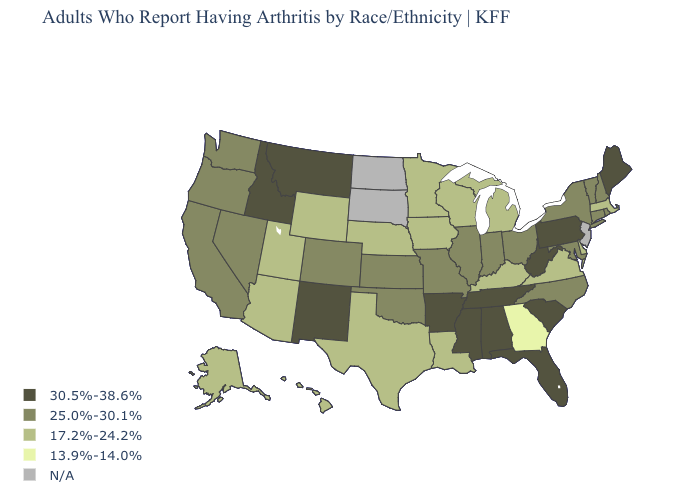Which states have the lowest value in the USA?
Give a very brief answer. Georgia. What is the value of Hawaii?
Answer briefly. 17.2%-24.2%. Name the states that have a value in the range 30.5%-38.6%?
Be succinct. Alabama, Arkansas, Florida, Idaho, Maine, Mississippi, Montana, New Mexico, Pennsylvania, South Carolina, Tennessee, West Virginia. Does the first symbol in the legend represent the smallest category?
Quick response, please. No. Name the states that have a value in the range 17.2%-24.2%?
Write a very short answer. Alaska, Arizona, Delaware, Hawaii, Iowa, Kentucky, Louisiana, Massachusetts, Michigan, Minnesota, Nebraska, Texas, Utah, Virginia, Wisconsin, Wyoming. Does Massachusetts have the lowest value in the Northeast?
Write a very short answer. Yes. Name the states that have a value in the range 25.0%-30.1%?
Give a very brief answer. California, Colorado, Connecticut, Illinois, Indiana, Kansas, Maryland, Missouri, Nevada, New Hampshire, New York, North Carolina, Ohio, Oklahoma, Oregon, Rhode Island, Vermont, Washington. Does New Hampshire have the highest value in the Northeast?
Keep it brief. No. Which states have the lowest value in the USA?
Write a very short answer. Georgia. Which states have the lowest value in the USA?
Quick response, please. Georgia. Does the first symbol in the legend represent the smallest category?
Quick response, please. No. What is the value of Alabama?
Keep it brief. 30.5%-38.6%. Name the states that have a value in the range N/A?
Give a very brief answer. New Jersey, North Dakota, South Dakota. 